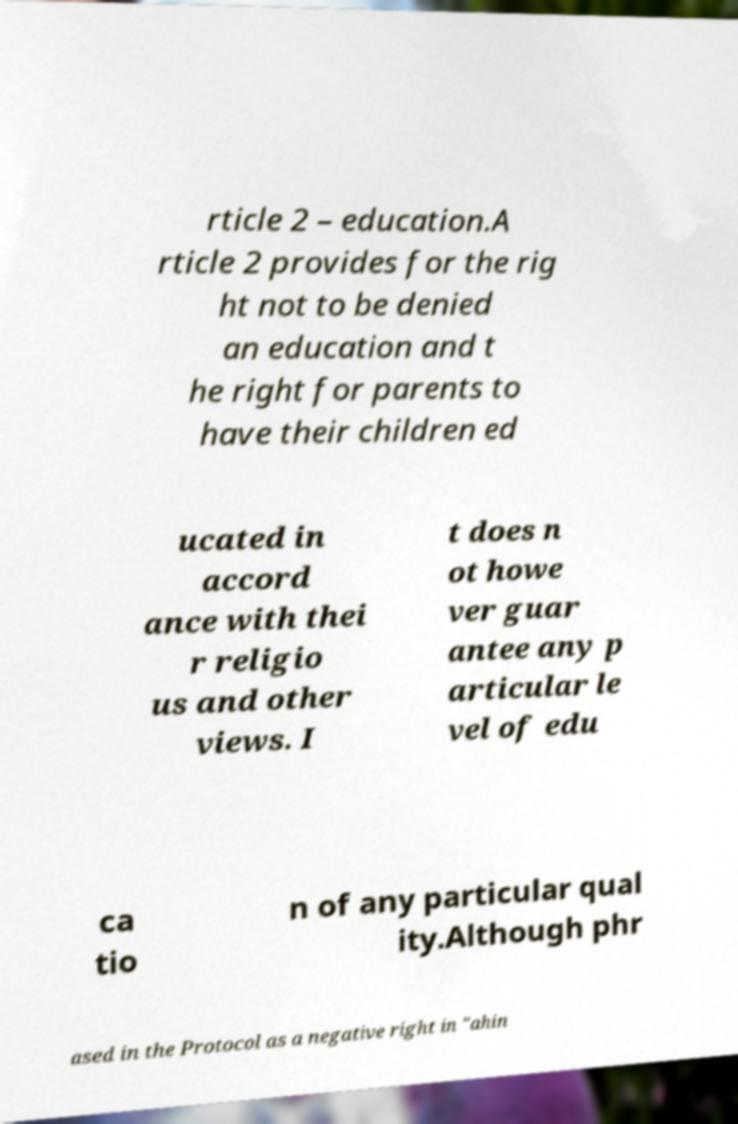Can you read and provide the text displayed in the image?This photo seems to have some interesting text. Can you extract and type it out for me? rticle 2 – education.A rticle 2 provides for the rig ht not to be denied an education and t he right for parents to have their children ed ucated in accord ance with thei r religio us and other views. I t does n ot howe ver guar antee any p articular le vel of edu ca tio n of any particular qual ity.Although phr ased in the Protocol as a negative right in "ahin 